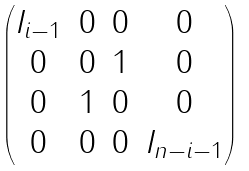<formula> <loc_0><loc_0><loc_500><loc_500>\begin{pmatrix} I _ { i - 1 } & 0 & 0 & 0 \\ 0 & 0 & 1 & 0 \\ 0 & 1 & 0 & 0 \\ 0 & 0 & 0 & I _ { n - i - 1 } \end{pmatrix}</formula> 